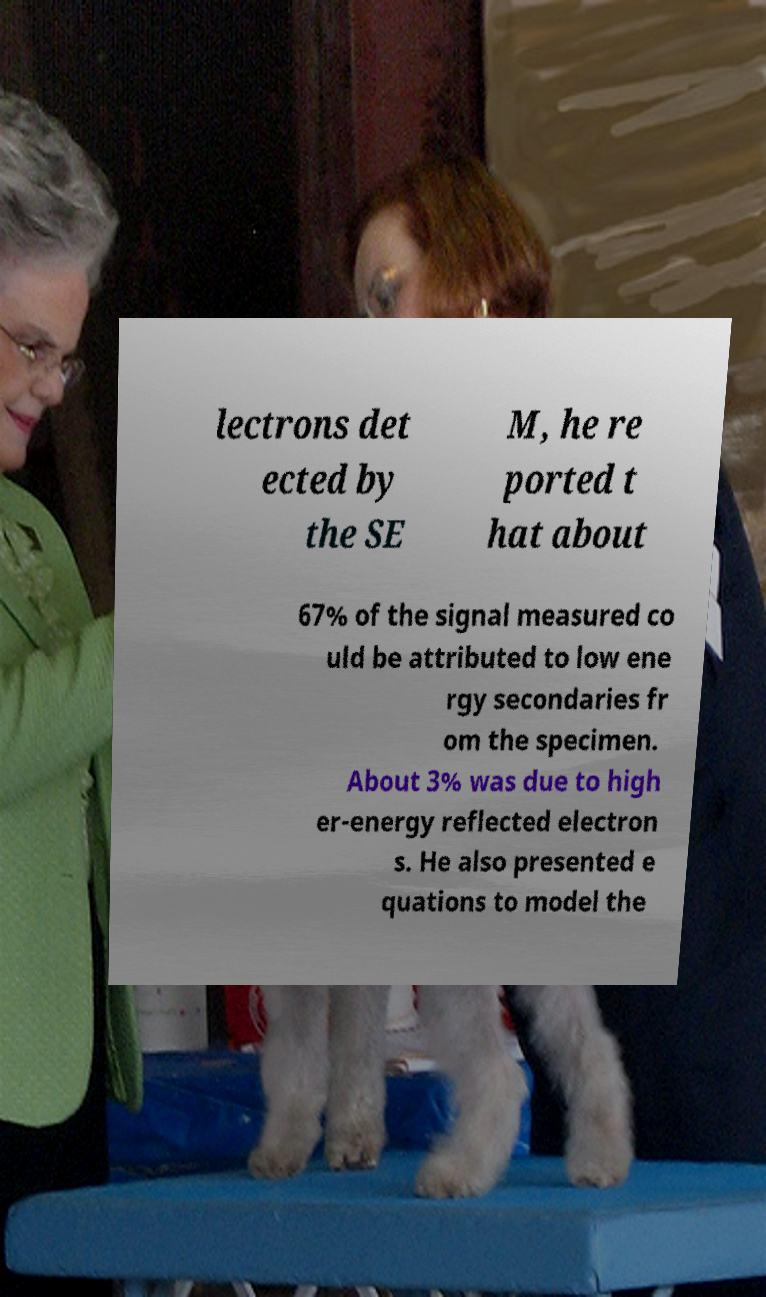I need the written content from this picture converted into text. Can you do that? lectrons det ected by the SE M, he re ported t hat about 67% of the signal measured co uld be attributed to low ene rgy secondaries fr om the specimen. About 3% was due to high er-energy reflected electron s. He also presented e quations to model the 